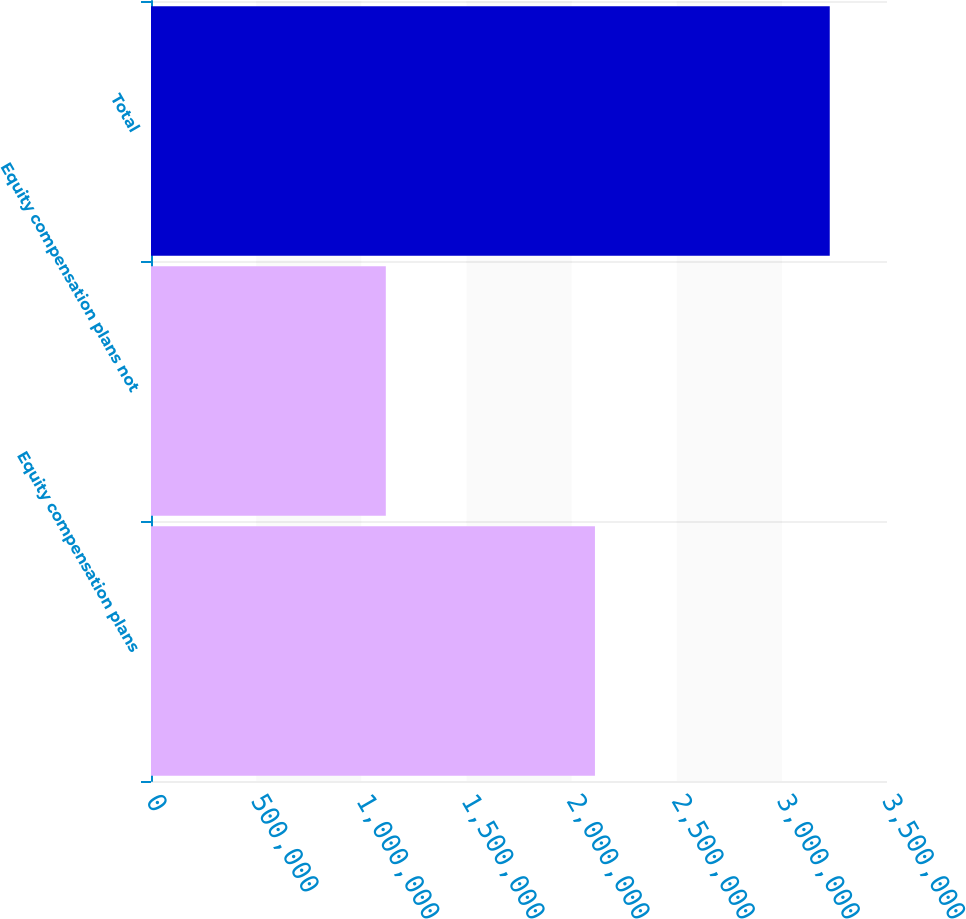Convert chart. <chart><loc_0><loc_0><loc_500><loc_500><bar_chart><fcel>Equity compensation plans<fcel>Equity compensation plans not<fcel>Total<nl><fcel>2.11114e+06<fcel>1.11662e+06<fcel>3.22775e+06<nl></chart> 